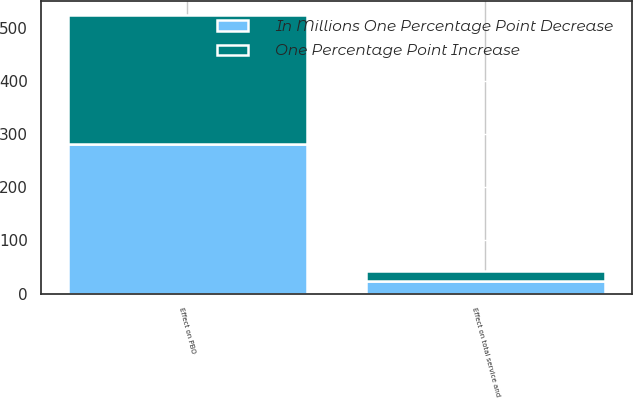Convert chart. <chart><loc_0><loc_0><loc_500><loc_500><stacked_bar_chart><ecel><fcel>Effect on total service and<fcel>Effect on PBO<nl><fcel>In Millions One Percentage Point Decrease<fcel>23<fcel>281<nl><fcel>One Percentage Point Increase<fcel>19<fcel>242<nl></chart> 